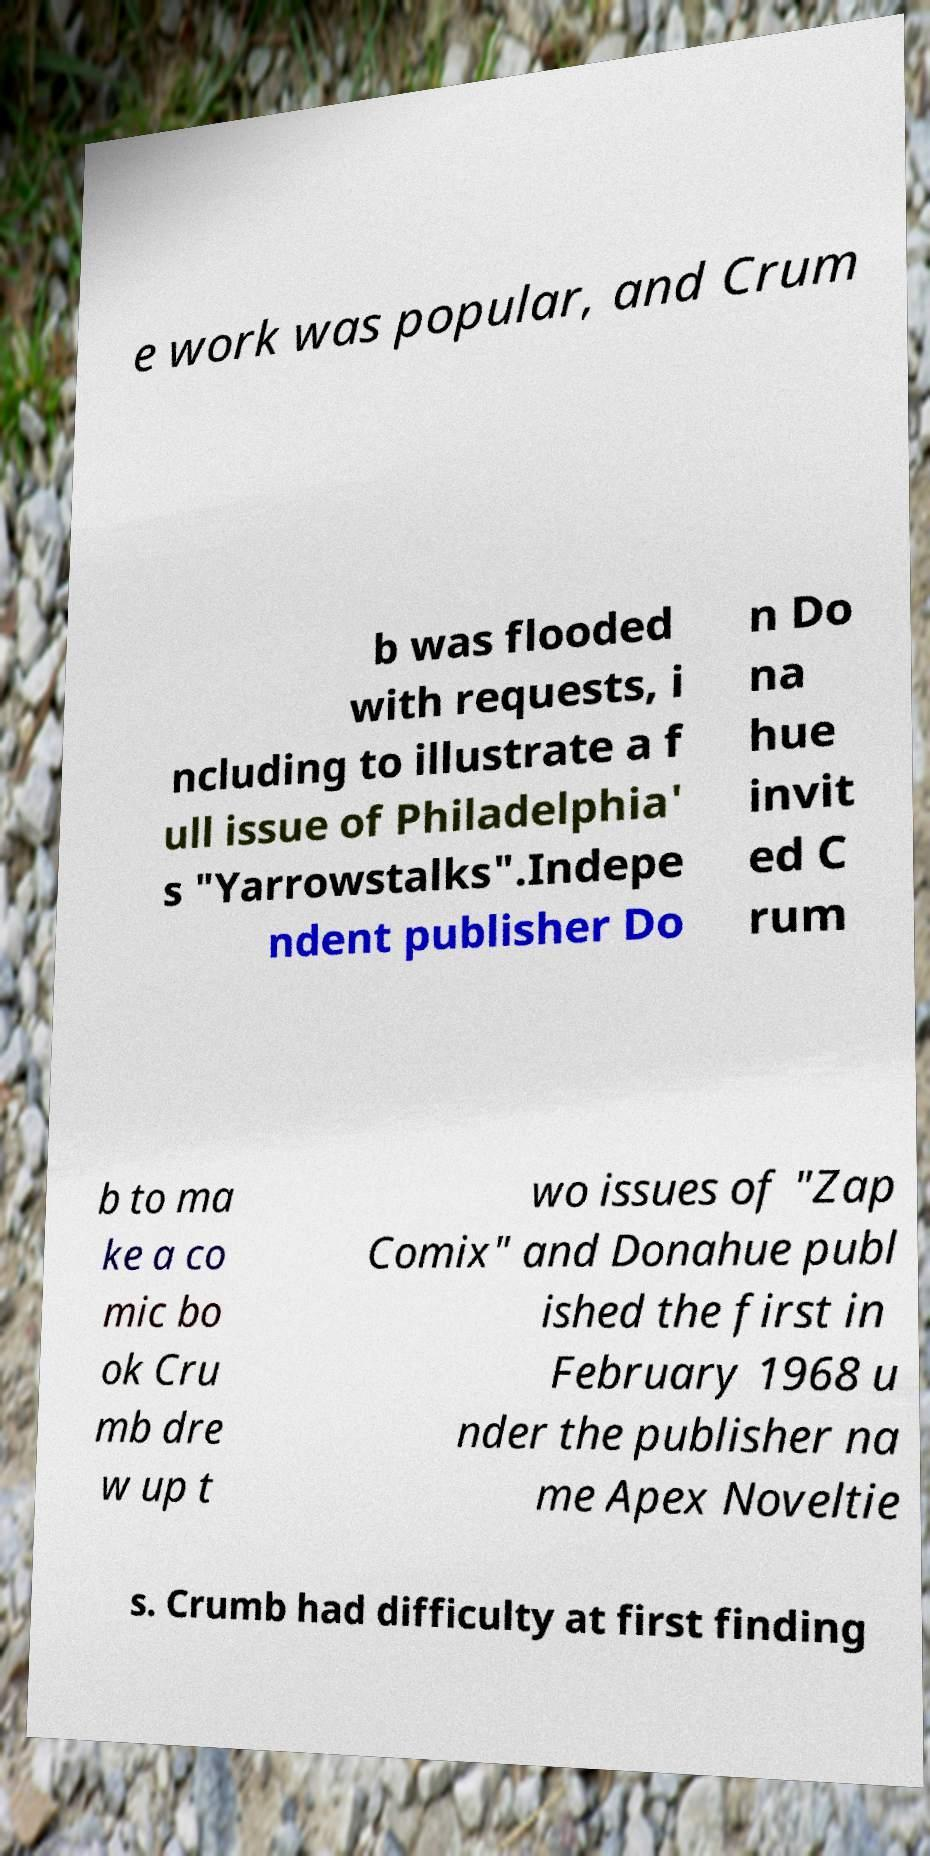For documentation purposes, I need the text within this image transcribed. Could you provide that? e work was popular, and Crum b was flooded with requests, i ncluding to illustrate a f ull issue of Philadelphia' s "Yarrowstalks".Indepe ndent publisher Do n Do na hue invit ed C rum b to ma ke a co mic bo ok Cru mb dre w up t wo issues of "Zap Comix" and Donahue publ ished the first in February 1968 u nder the publisher na me Apex Noveltie s. Crumb had difficulty at first finding 